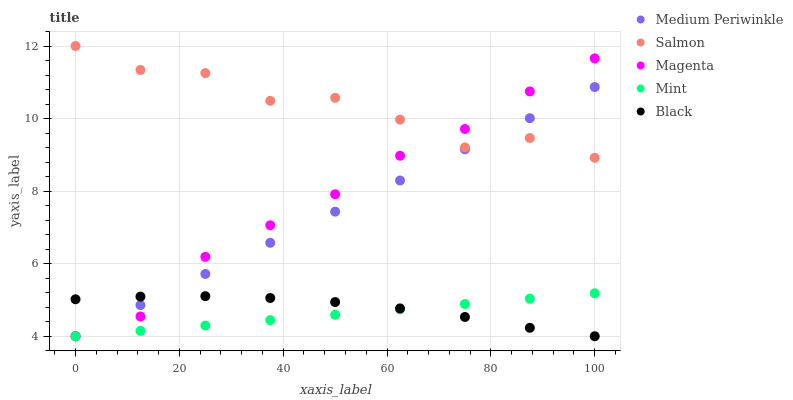Does Mint have the minimum area under the curve?
Answer yes or no. Yes. Does Salmon have the maximum area under the curve?
Answer yes or no. Yes. Does Magenta have the minimum area under the curve?
Answer yes or no. No. Does Magenta have the maximum area under the curve?
Answer yes or no. No. Is Mint the smoothest?
Answer yes or no. Yes. Is Salmon the roughest?
Answer yes or no. Yes. Is Magenta the smoothest?
Answer yes or no. No. Is Magenta the roughest?
Answer yes or no. No. Does Magenta have the lowest value?
Answer yes or no. Yes. Does Salmon have the highest value?
Answer yes or no. Yes. Does Magenta have the highest value?
Answer yes or no. No. Is Mint less than Salmon?
Answer yes or no. Yes. Is Salmon greater than Mint?
Answer yes or no. Yes. Does Mint intersect Medium Periwinkle?
Answer yes or no. Yes. Is Mint less than Medium Periwinkle?
Answer yes or no. No. Is Mint greater than Medium Periwinkle?
Answer yes or no. No. Does Mint intersect Salmon?
Answer yes or no. No. 